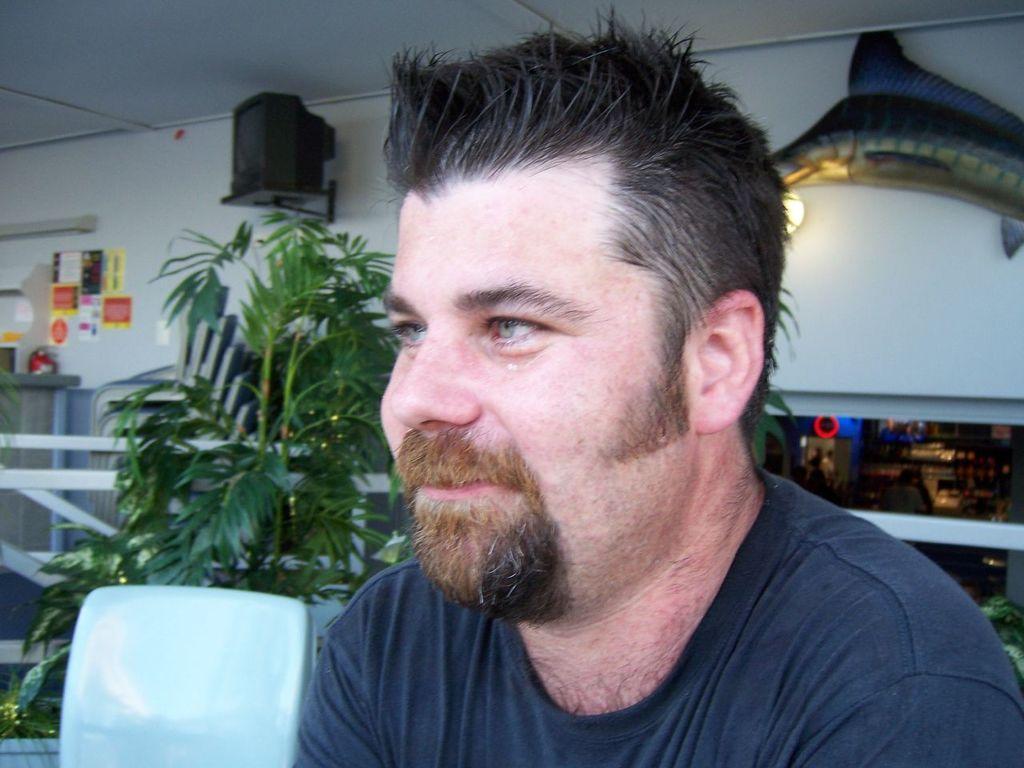Can you describe this image briefly? In the picture I can see a man. In the background I can see plants, fence, ceiling, lights and some other objects attached to the wall. 